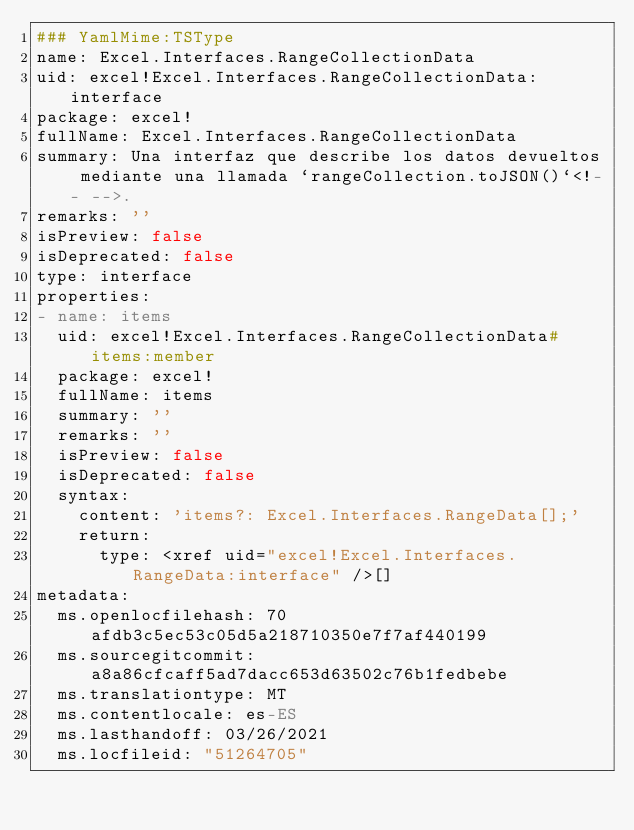Convert code to text. <code><loc_0><loc_0><loc_500><loc_500><_YAML_>### YamlMime:TSType
name: Excel.Interfaces.RangeCollectionData
uid: excel!Excel.Interfaces.RangeCollectionData:interface
package: excel!
fullName: Excel.Interfaces.RangeCollectionData
summary: Una interfaz que describe los datos devueltos mediante una llamada `rangeCollection.toJSON()`<!-- -->.
remarks: ''
isPreview: false
isDeprecated: false
type: interface
properties:
- name: items
  uid: excel!Excel.Interfaces.RangeCollectionData#items:member
  package: excel!
  fullName: items
  summary: ''
  remarks: ''
  isPreview: false
  isDeprecated: false
  syntax:
    content: 'items?: Excel.Interfaces.RangeData[];'
    return:
      type: <xref uid="excel!Excel.Interfaces.RangeData:interface" />[]
metadata:
  ms.openlocfilehash: 70afdb3c5ec53c05d5a218710350e7f7af440199
  ms.sourcegitcommit: a8a86cfcaff5ad7dacc653d63502c76b1fedbebe
  ms.translationtype: MT
  ms.contentlocale: es-ES
  ms.lasthandoff: 03/26/2021
  ms.locfileid: "51264705"
</code> 